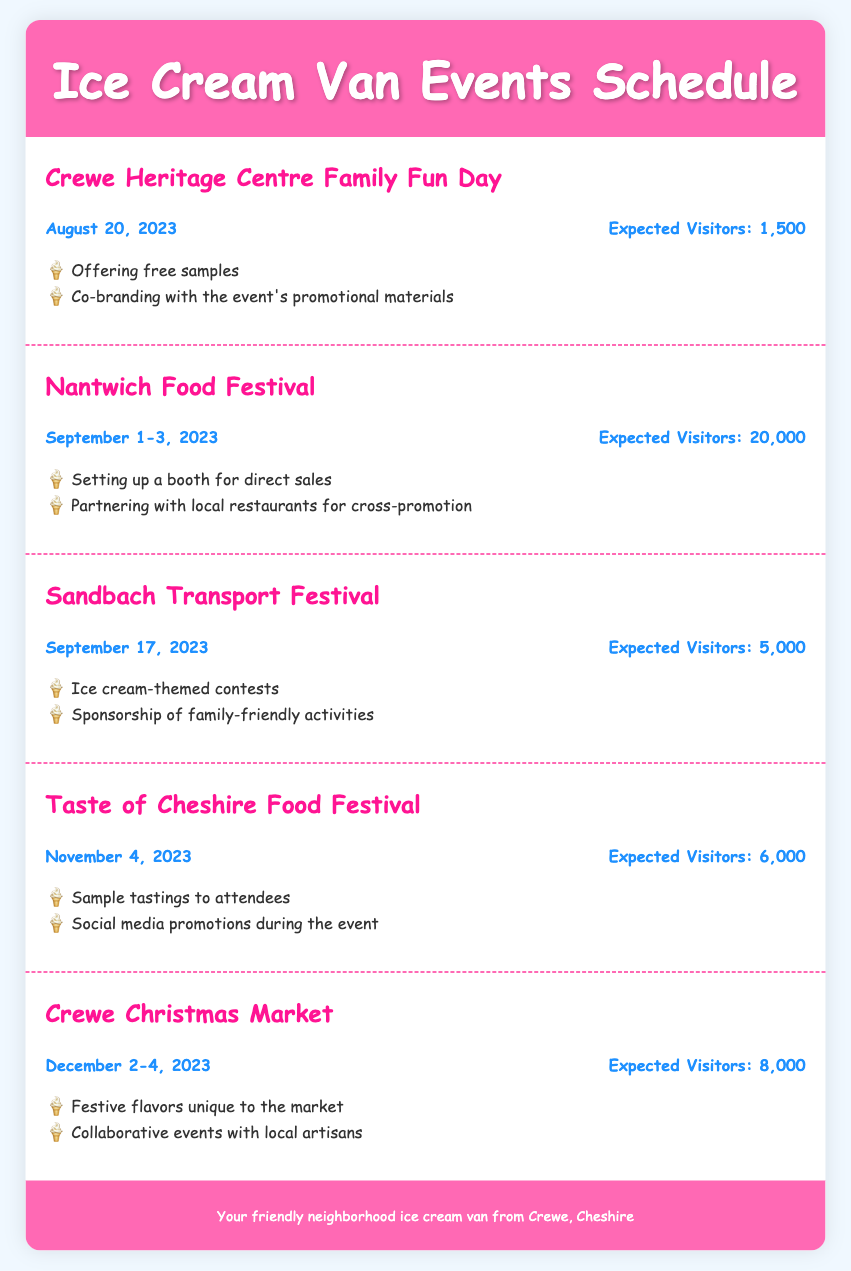What is the date of the Crewe Heritage Centre Family Fun Day? The date is mentioned in the event details and is stated as August 20, 2023.
Answer: August 20, 2023 How many expected visitors are there for the Nantwich Food Festival? The expected visitors are listed in the event details, totaling 20,000.
Answer: 20,000 What promotional opportunity is mentioned for the Sandbach Transport Festival? One of the opportunities mentioned is the sponsorship of family-friendly activities, indicating a way to engage with attendees.
Answer: Sponsorship of family-friendly activities Which event takes place in December? The document lists the Crewe Christmas Market, which is scheduled for December 2-4, 2023.
Answer: Crewe Christmas Market What is the total expected foot traffic for all events listed? The total visitors can be calculated by adding the expected visitors for each event: 1,500 + 20,000 + 5,000 + 6,000 + 8,000 = 40,500.
Answer: 40,500 What is a unique feature for the ice cream offerings at the Crewe Christmas Market? The document mentions festive flavors unique to the market, highlighting a special product offering for that event.
Answer: Festive flavors unique to the market How long is the Nantwich Food Festival? The duration of the festival is specified in the event details as a three-day event from September 1-3, 2023.
Answer: September 1-3, 2023 Which event is expected to have the least foot traffic? Based on the expected visitors, the Crewe Heritage Centre Family Fun Day has the least expected foot traffic at 1,500.
Answer: Crewe Heritage Centre Family Fun Day 